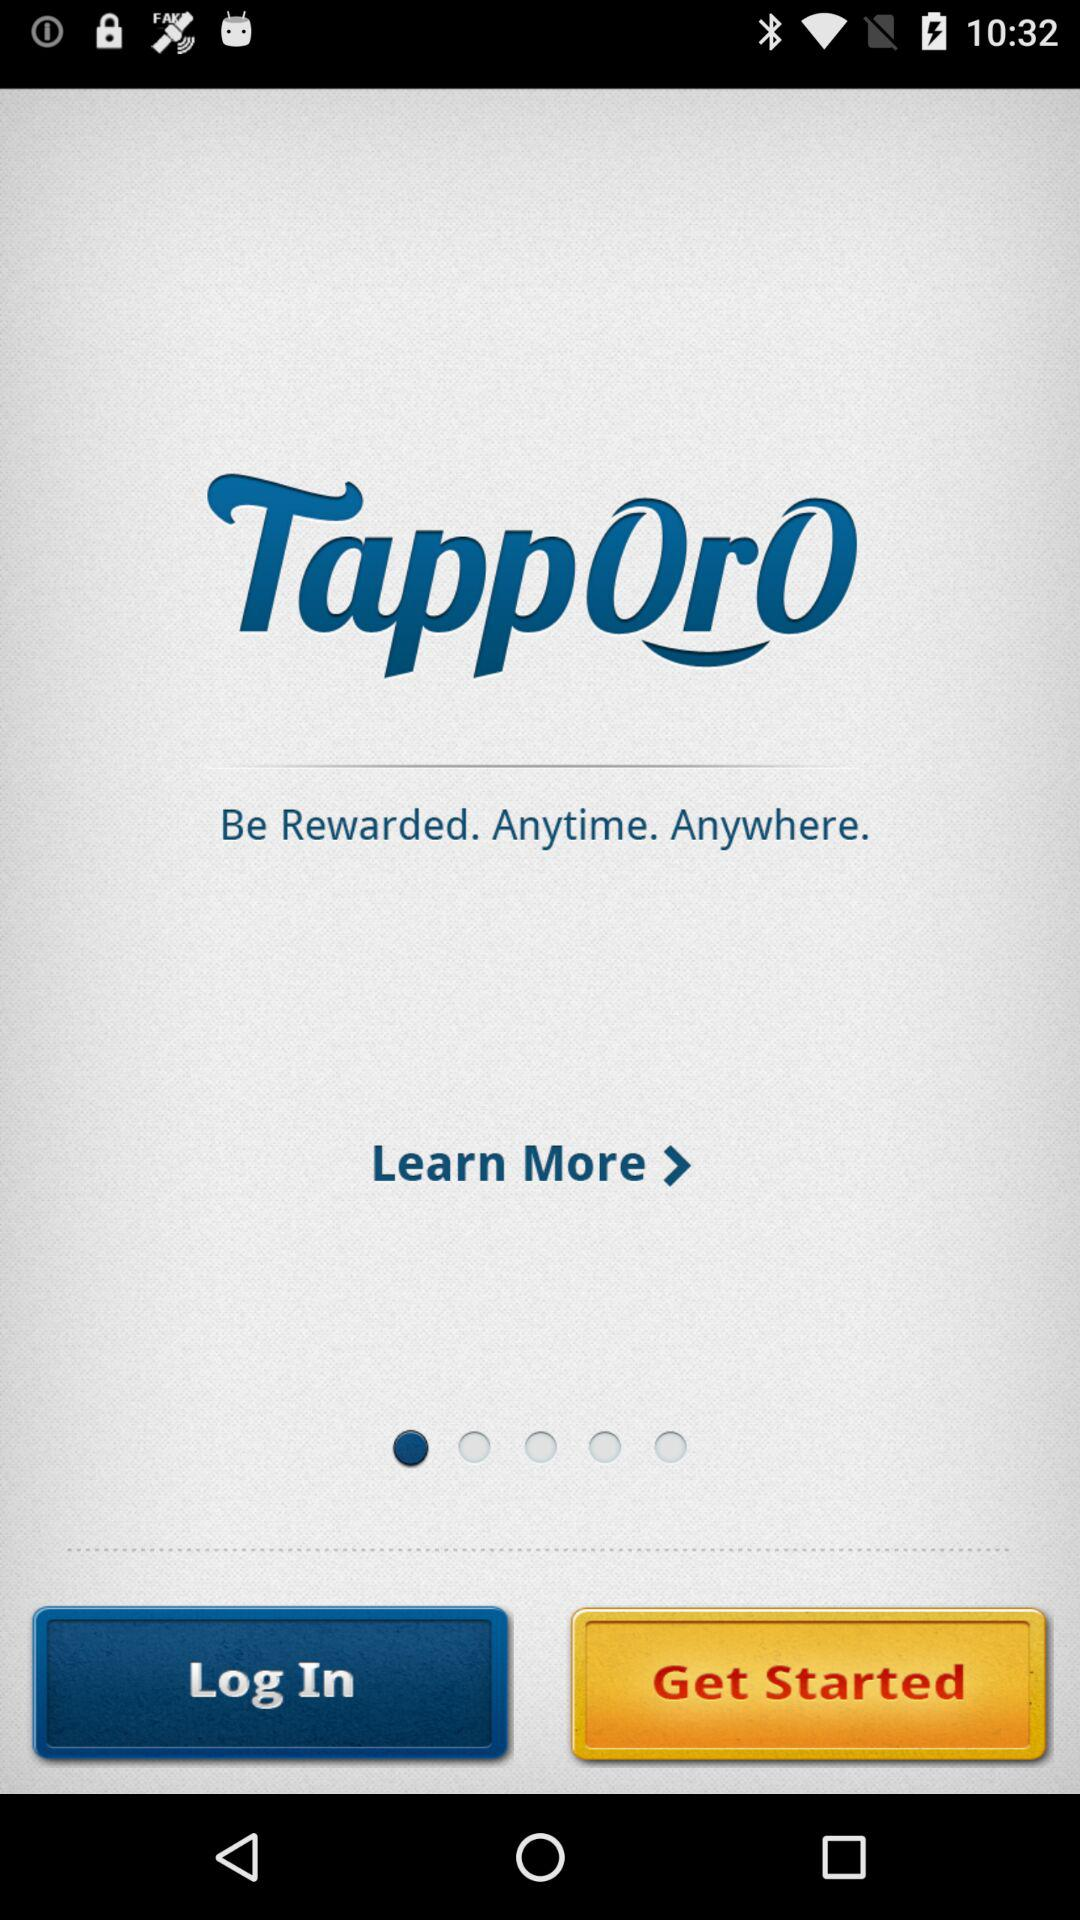What is the application name? The application name is "Tapporo". 